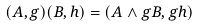Convert formula to latex. <formula><loc_0><loc_0><loc_500><loc_500>( A , g ) ( B , h ) = ( A \wedge g B , g h )</formula> 